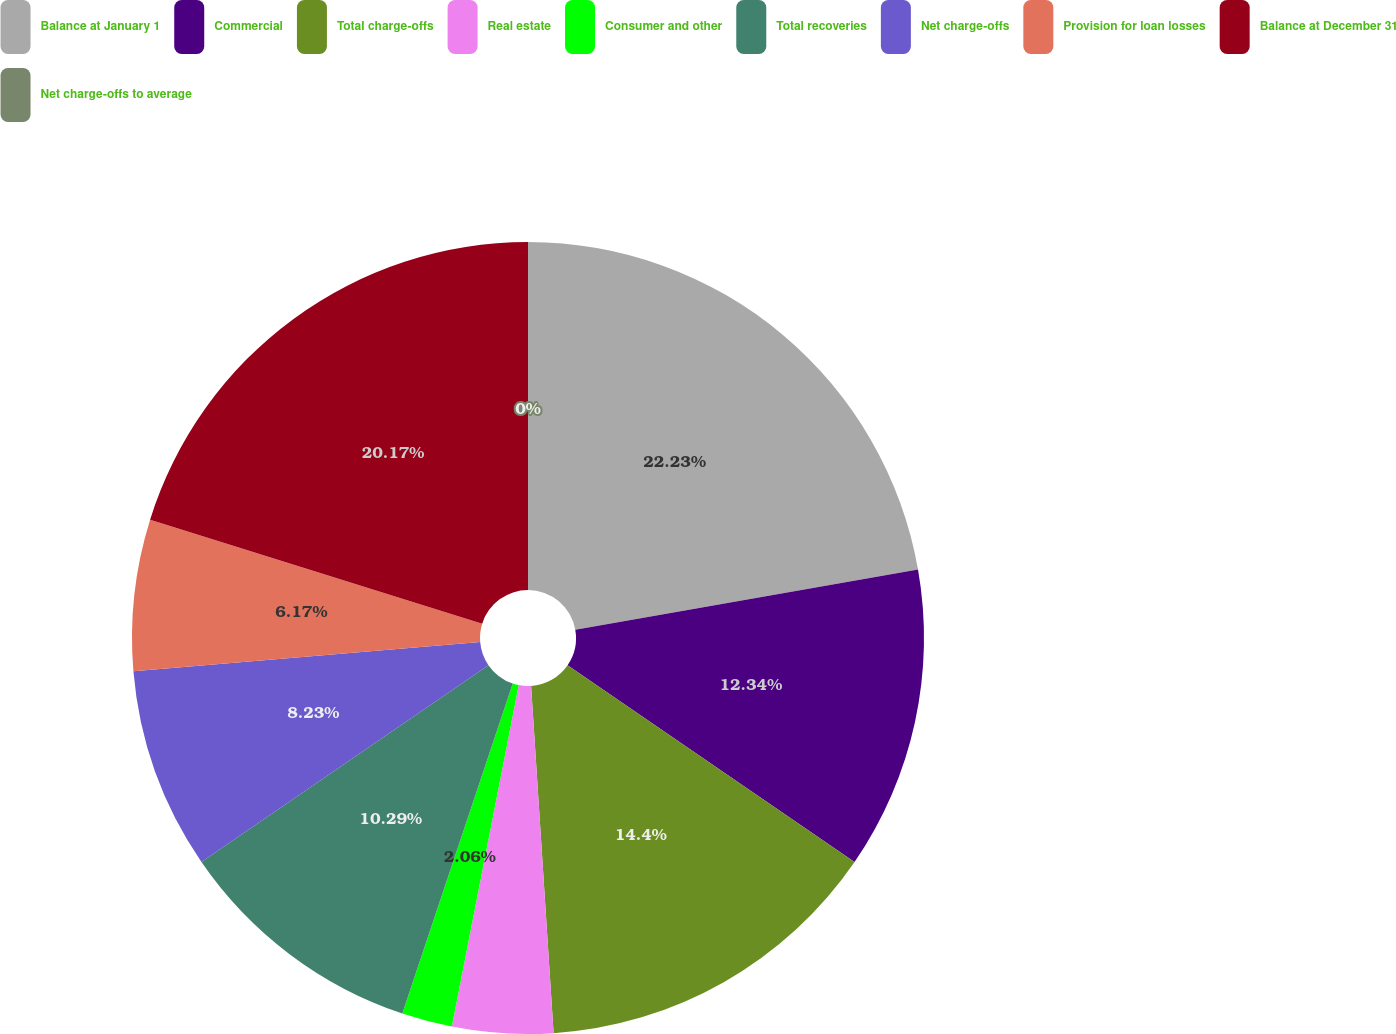<chart> <loc_0><loc_0><loc_500><loc_500><pie_chart><fcel>Balance at January 1<fcel>Commercial<fcel>Total charge-offs<fcel>Real estate<fcel>Consumer and other<fcel>Total recoveries<fcel>Net charge-offs<fcel>Provision for loan losses<fcel>Balance at December 31<fcel>Net charge-offs to average<nl><fcel>22.23%<fcel>12.34%<fcel>14.4%<fcel>4.11%<fcel>2.06%<fcel>10.29%<fcel>8.23%<fcel>6.17%<fcel>20.17%<fcel>0.0%<nl></chart> 